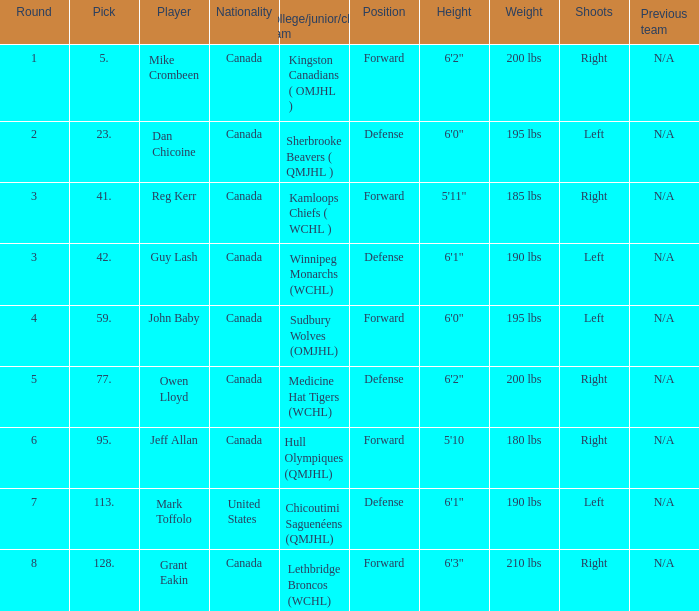Which College/junior/club team has a Round of 2? Sherbrooke Beavers ( QMJHL ). 